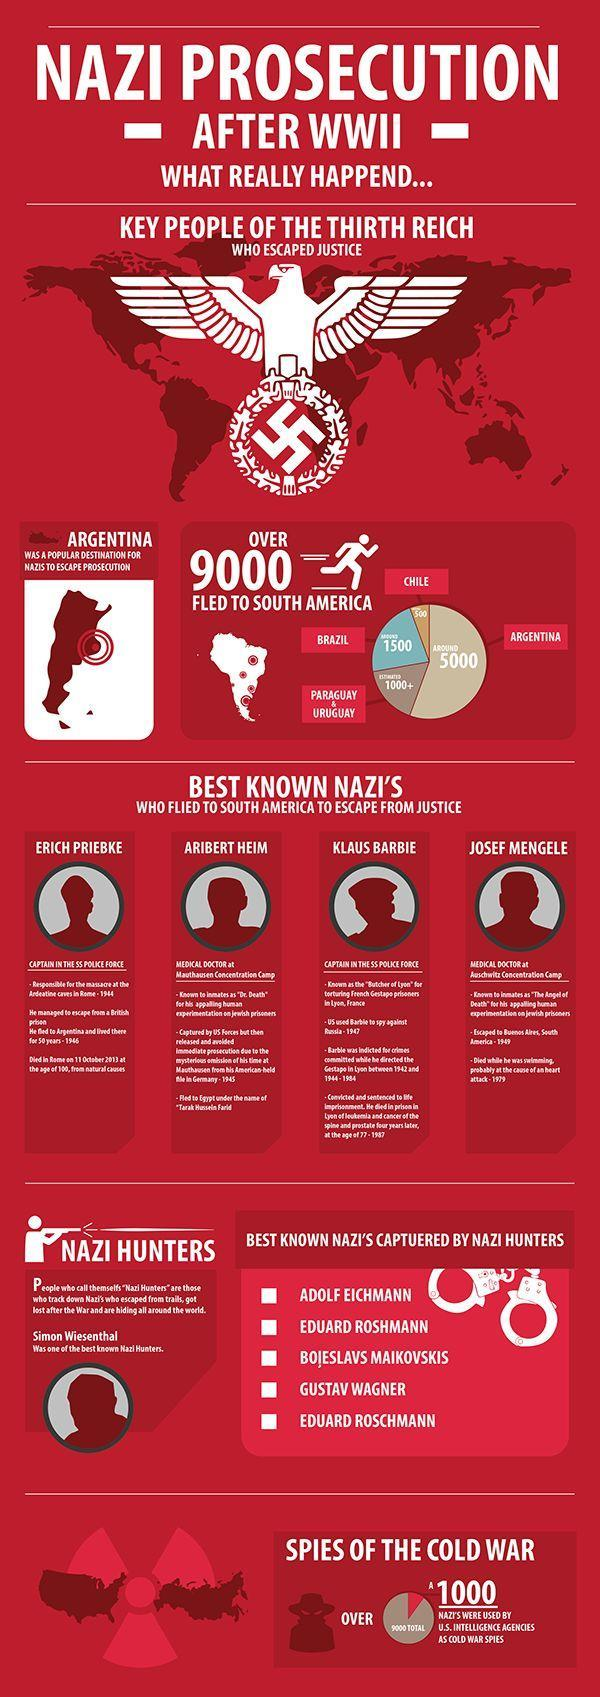What number of Nazi spies were not working for America?
Answer the question with a short phrase. 8000 Who is the famous Nazi listed second in the infographic caught by Nazi Antagonists? Eduard Roshmann How many Nazi spies were there during the cold war? 9000 Who is the famous Nazi listed fourth in the infographic caught by Nazi Antagonists? Gustav Wagner To which country in South America second-most of the Nazis moved during World War 2? Brazil To which country in South America third majority of the Nazis moved during world war 2? Paraguay & Uruguay 